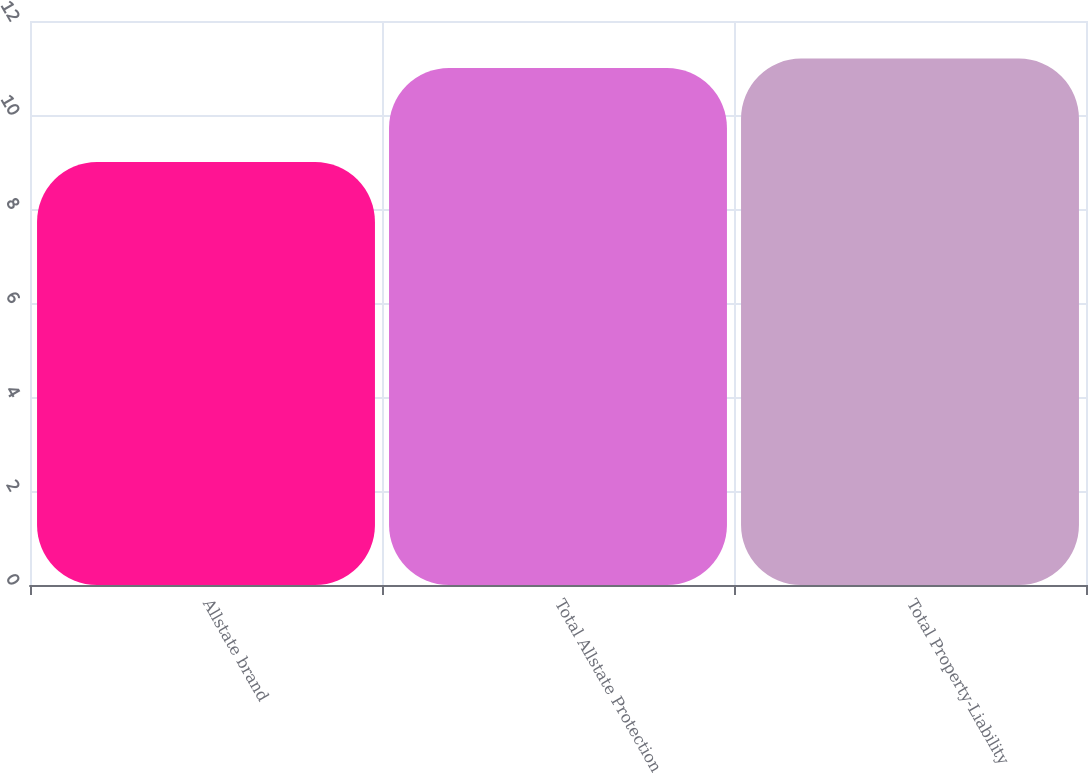Convert chart. <chart><loc_0><loc_0><loc_500><loc_500><bar_chart><fcel>Allstate brand<fcel>Total Allstate Protection<fcel>Total Property-Liability<nl><fcel>9<fcel>11<fcel>11.2<nl></chart> 